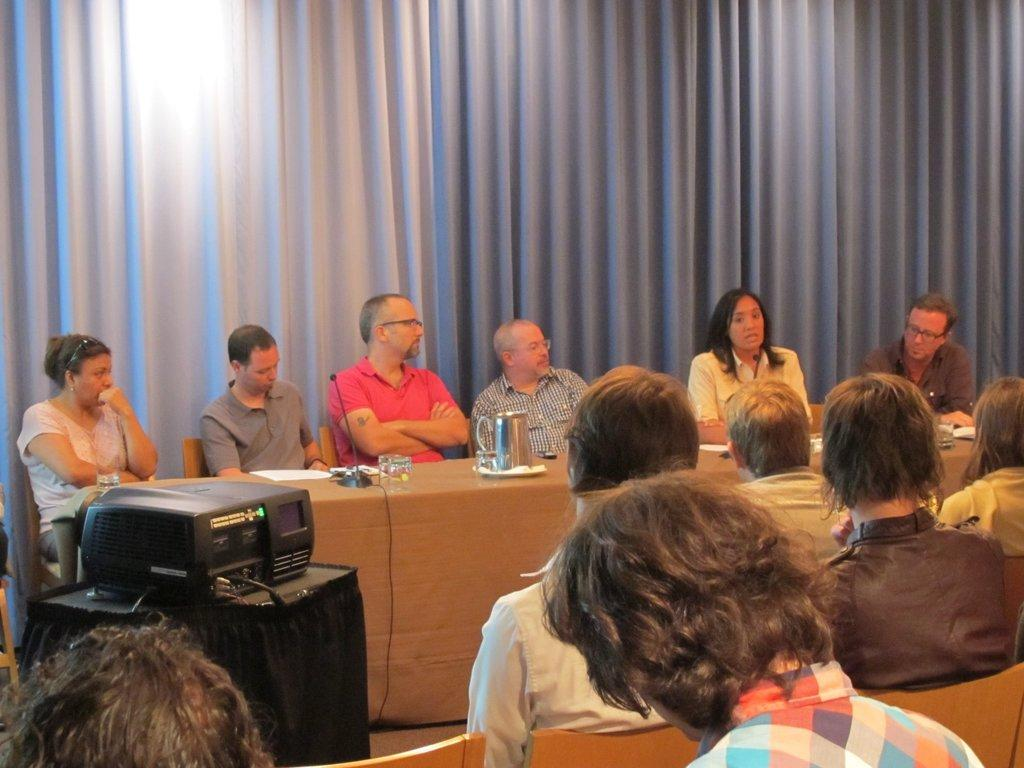What type of window treatment is visible in the image? There are curtains in the image. What are the people in the image doing? They are sitting on chairs in the image. What device is used for displaying visuals in the image? There is a projector in the image. What piece of furniture is present in the image? There is a table in the image. What items can be seen on the table in the image? There is a mug and a plate on the table in the image. How many bikes are parked near the table in the image? There are no bikes present in the image. What type of gardening tool is being used by the people sitting on chairs in the image? There is no gardening tool, such as a rake, present in the image. 